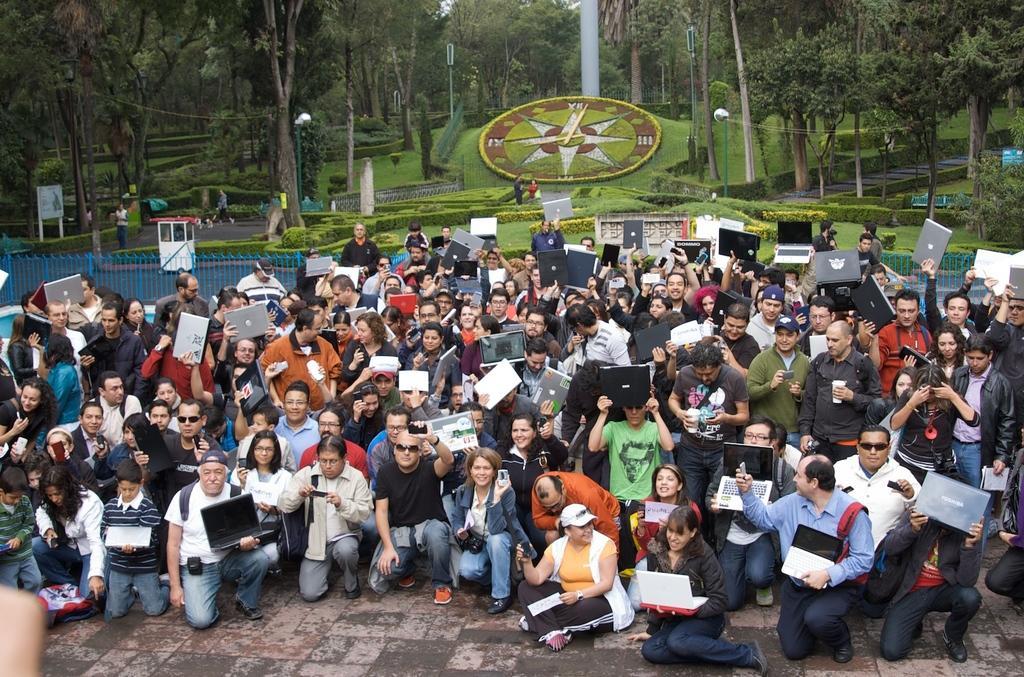Could you give a brief overview of what you see in this image? In this image we can see many people. Some are holding laptops. Some are wearing caps. Some are wearing goggles. In the back there are railings, bushes, trees. On the ground there is grass. Also there are lights poles. And there is a board with poles on the left side. 